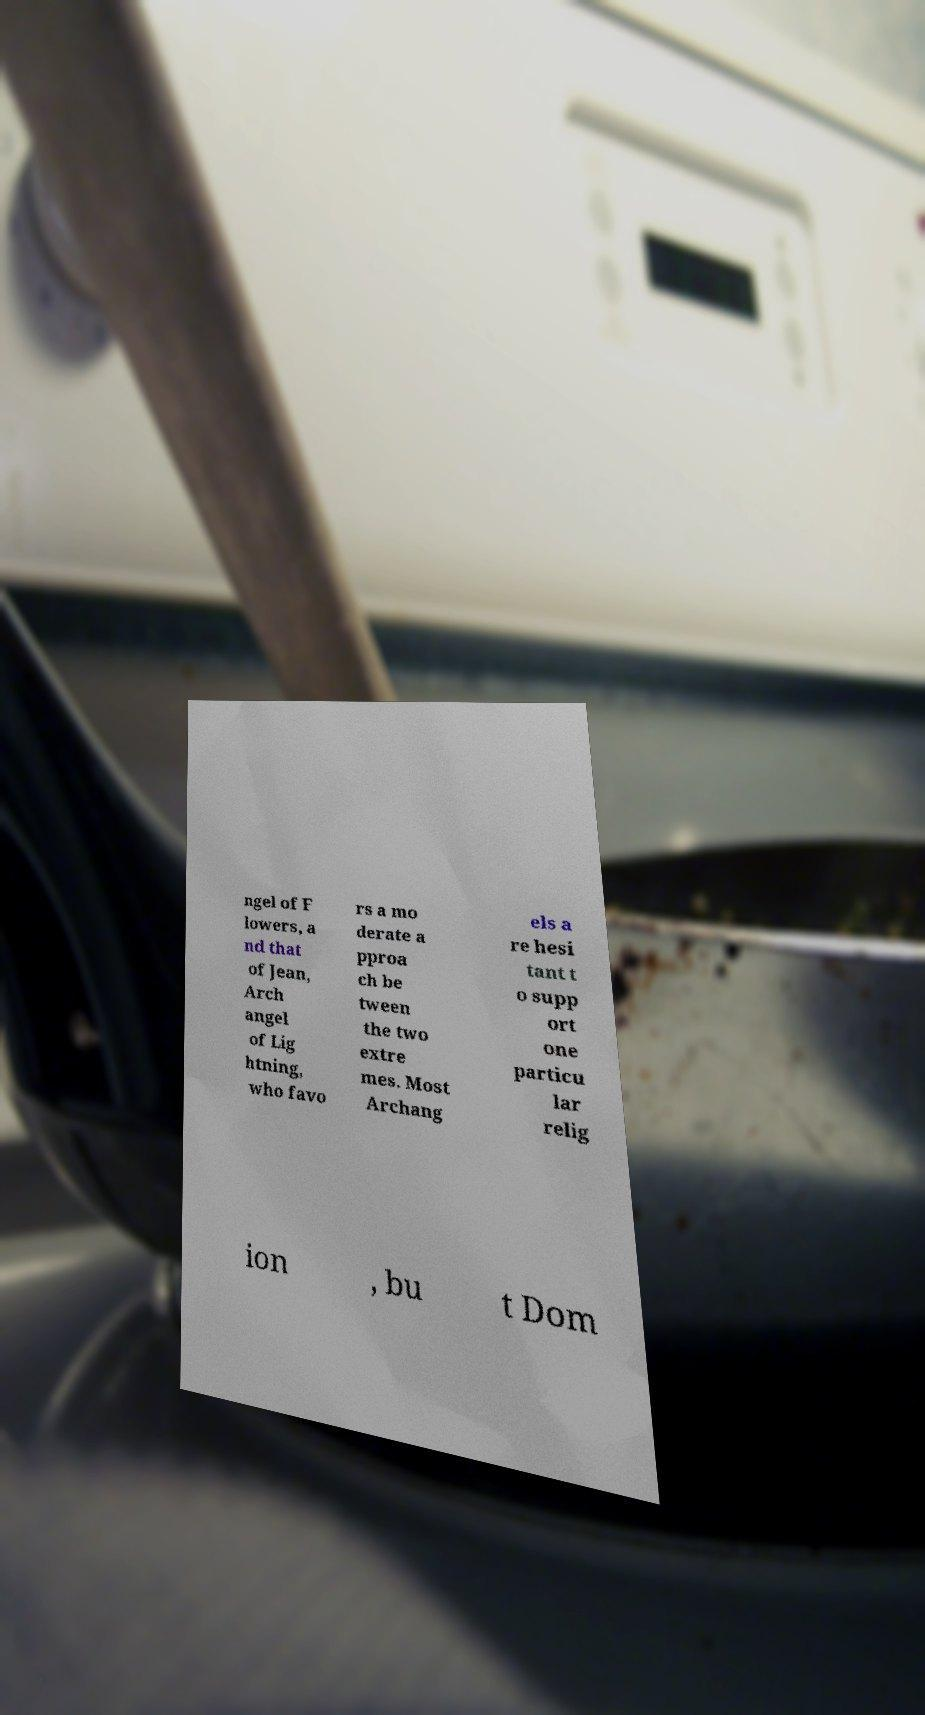Can you accurately transcribe the text from the provided image for me? ngel of F lowers, a nd that of Jean, Arch angel of Lig htning, who favo rs a mo derate a pproa ch be tween the two extre mes. Most Archang els a re hesi tant t o supp ort one particu lar relig ion , bu t Dom 